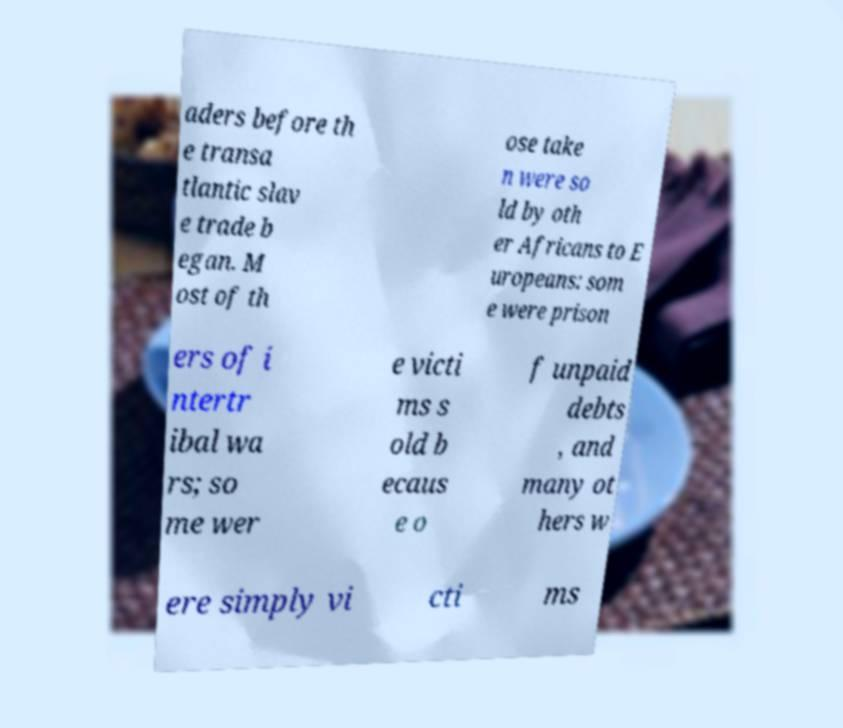Please read and relay the text visible in this image. What does it say? aders before th e transa tlantic slav e trade b egan. M ost of th ose take n were so ld by oth er Africans to E uropeans: som e were prison ers of i ntertr ibal wa rs; so me wer e victi ms s old b ecaus e o f unpaid debts , and many ot hers w ere simply vi cti ms 